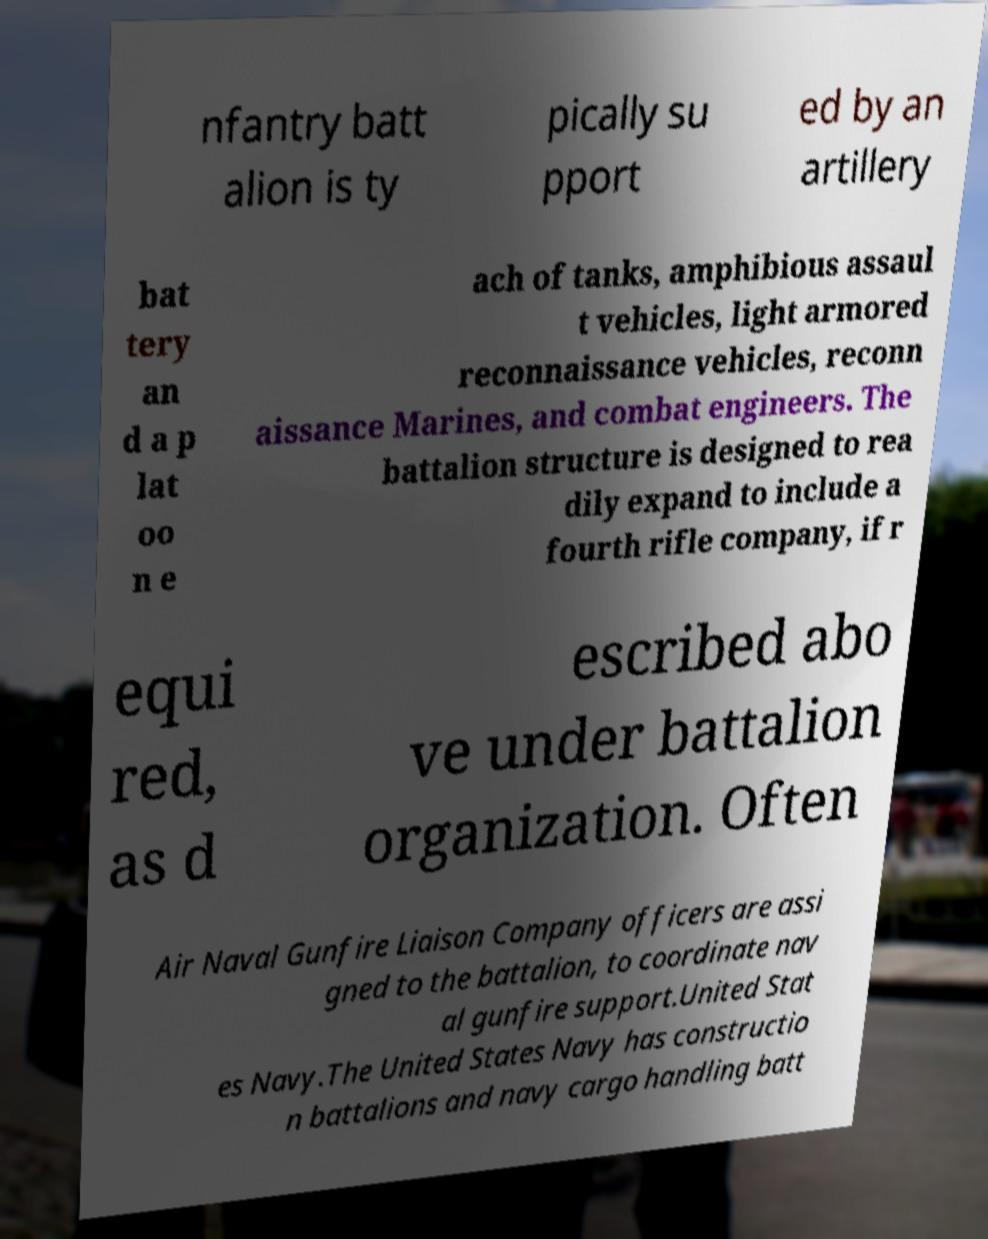I need the written content from this picture converted into text. Can you do that? nfantry batt alion is ty pically su pport ed by an artillery bat tery an d a p lat oo n e ach of tanks, amphibious assaul t vehicles, light armored reconnaissance vehicles, reconn aissance Marines, and combat engineers. The battalion structure is designed to rea dily expand to include a fourth rifle company, if r equi red, as d escribed abo ve under battalion organization. Often Air Naval Gunfire Liaison Company officers are assi gned to the battalion, to coordinate nav al gunfire support.United Stat es Navy.The United States Navy has constructio n battalions and navy cargo handling batt 